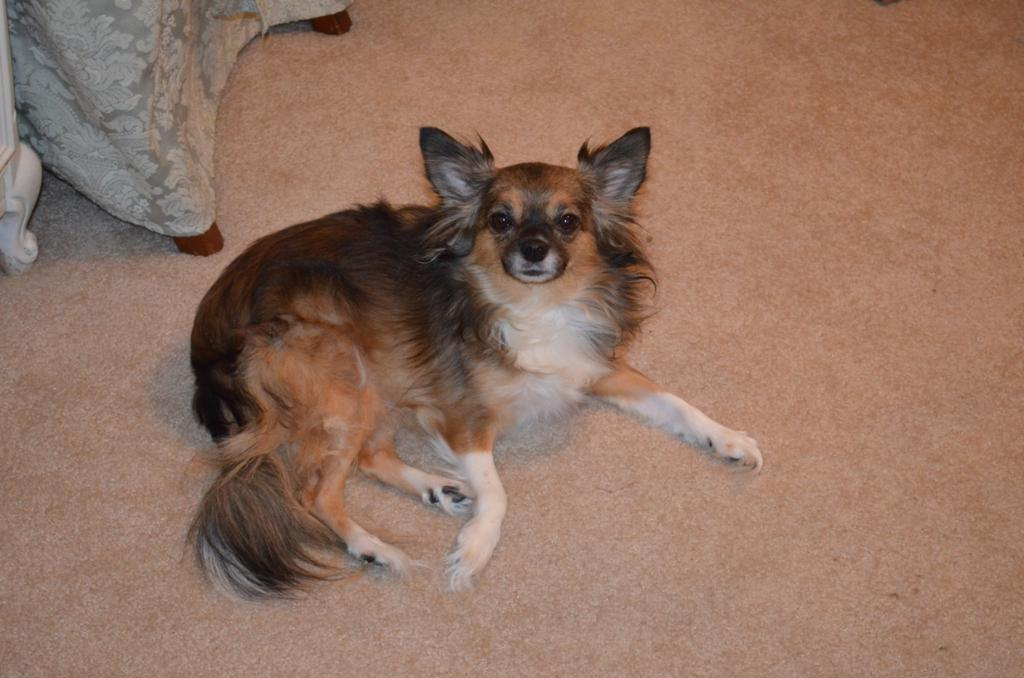What type of animal is in the image? There is a dog in the image. What colors can be seen on the dog? The dog has black, brown, and white colors. What is the dog standing on in the image? The dog is on a brown surface. What other object is present in the image besides the dog? There is a cloth in the image. What color is the cloth? The cloth is in ash color. How many spiders are crawling on the dog in the image? There are no spiders visible in the image; it only features a dog and a cloth. What is the relation between the dog and the cloth in the image? The image does not provide any information about the relationship between the dog and the cloth; they are simply two separate objects in the same scene. 